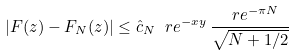<formula> <loc_0><loc_0><loc_500><loc_500>| F ( z ) - F _ { N } ( z ) | \leq \hat { c } _ { N } \ r e ^ { - x y } \, \frac { \ r e ^ { - \pi N } } { \sqrt { N + 1 / 2 } }</formula> 